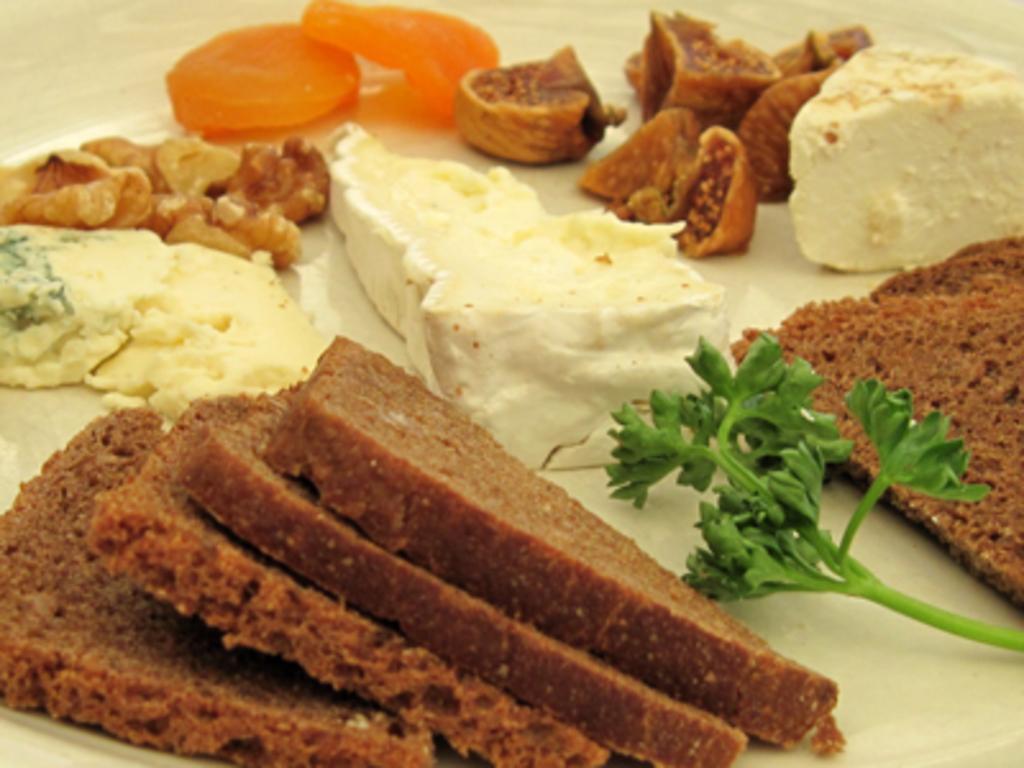Please provide a concise description of this image. In this image, we can see some eatable things and items are placed on the white surface. 